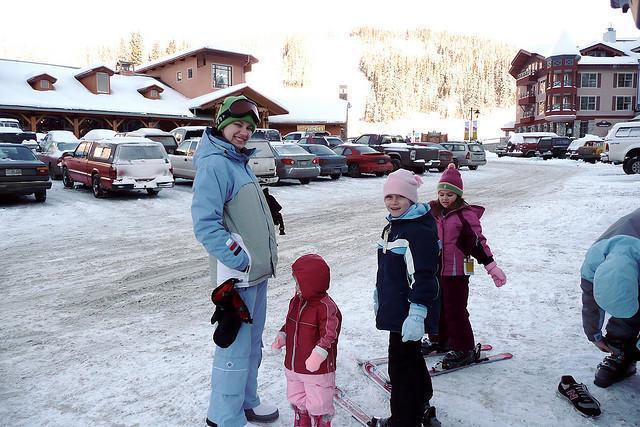How many cars are in the photo?
Give a very brief answer. 3. How many people are in the photo?
Give a very brief answer. 5. How many bird feeders are there?
Give a very brief answer. 0. 